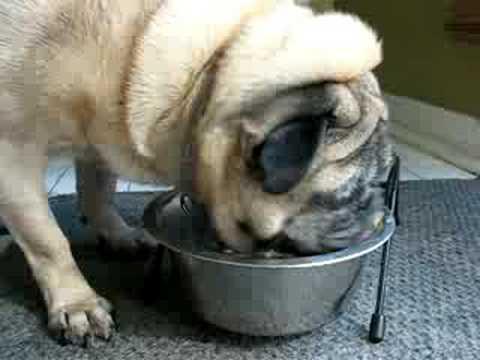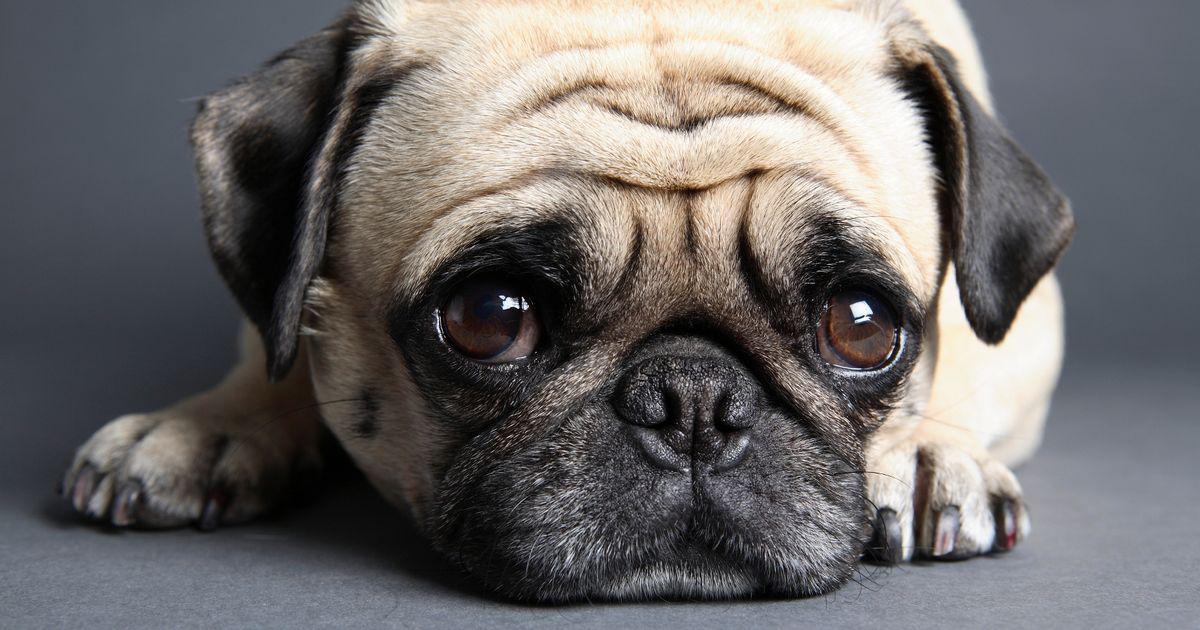The first image is the image on the left, the second image is the image on the right. For the images shown, is this caption "One dog is standing with his face bent down in a bowl, and the other dog is looking at the camera." true? Answer yes or no. Yes. The first image is the image on the left, the second image is the image on the right. For the images shown, is this caption "In one of the images there is one dog and one round silver dog food dish." true? Answer yes or no. Yes. 